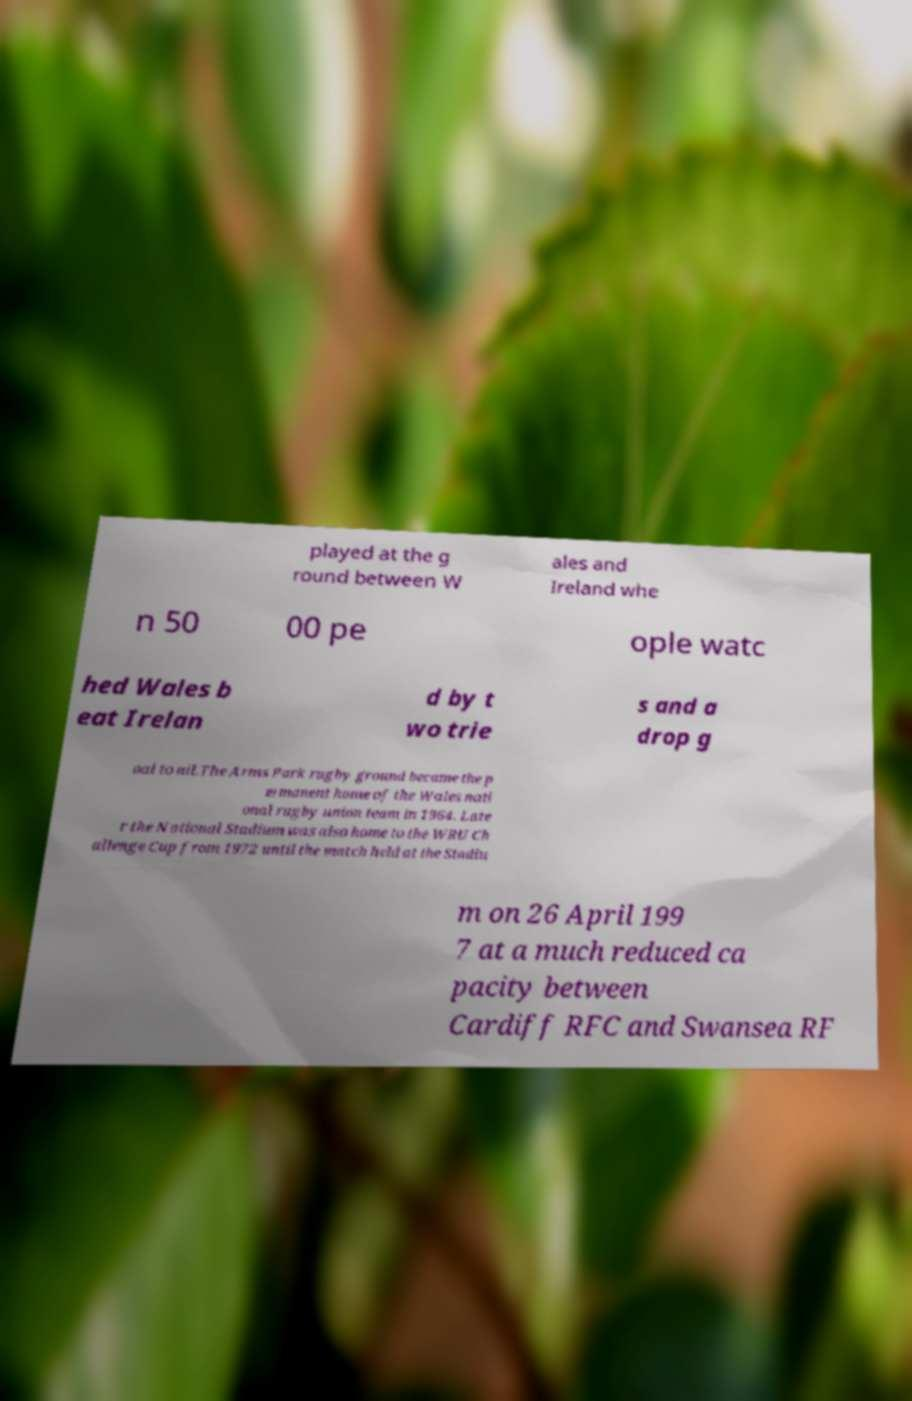I need the written content from this picture converted into text. Can you do that? played at the g round between W ales and Ireland whe n 50 00 pe ople watc hed Wales b eat Irelan d by t wo trie s and a drop g oal to nil.The Arms Park rugby ground became the p ermanent home of the Wales nati onal rugby union team in 1964. Late r the National Stadium was also home to the WRU Ch allenge Cup from 1972 until the match held at the Stadiu m on 26 April 199 7 at a much reduced ca pacity between Cardiff RFC and Swansea RF 